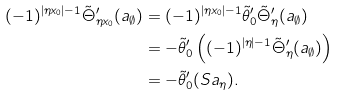<formula> <loc_0><loc_0><loc_500><loc_500>( - 1 ) ^ { | \eta x _ { 0 } | - 1 } \tilde { \Theta } ^ { \prime } _ { \eta x _ { 0 } } ( a _ { \emptyset } ) & = ( - 1 ) ^ { | \eta x _ { 0 } | - 1 } \tilde { \theta } ^ { \prime } _ { 0 } \tilde { \Theta } ^ { \prime } _ { \eta } ( a _ { \emptyset } ) \\ & = - \tilde { \theta } ^ { \prime } _ { 0 } \left ( ( - 1 ) ^ { | \eta | - 1 } \tilde { \Theta } ^ { \prime } _ { \eta } ( a _ { \emptyset } ) \right ) \\ & = - \tilde { \theta } ^ { \prime } _ { 0 } ( S a _ { \eta } ) .</formula> 